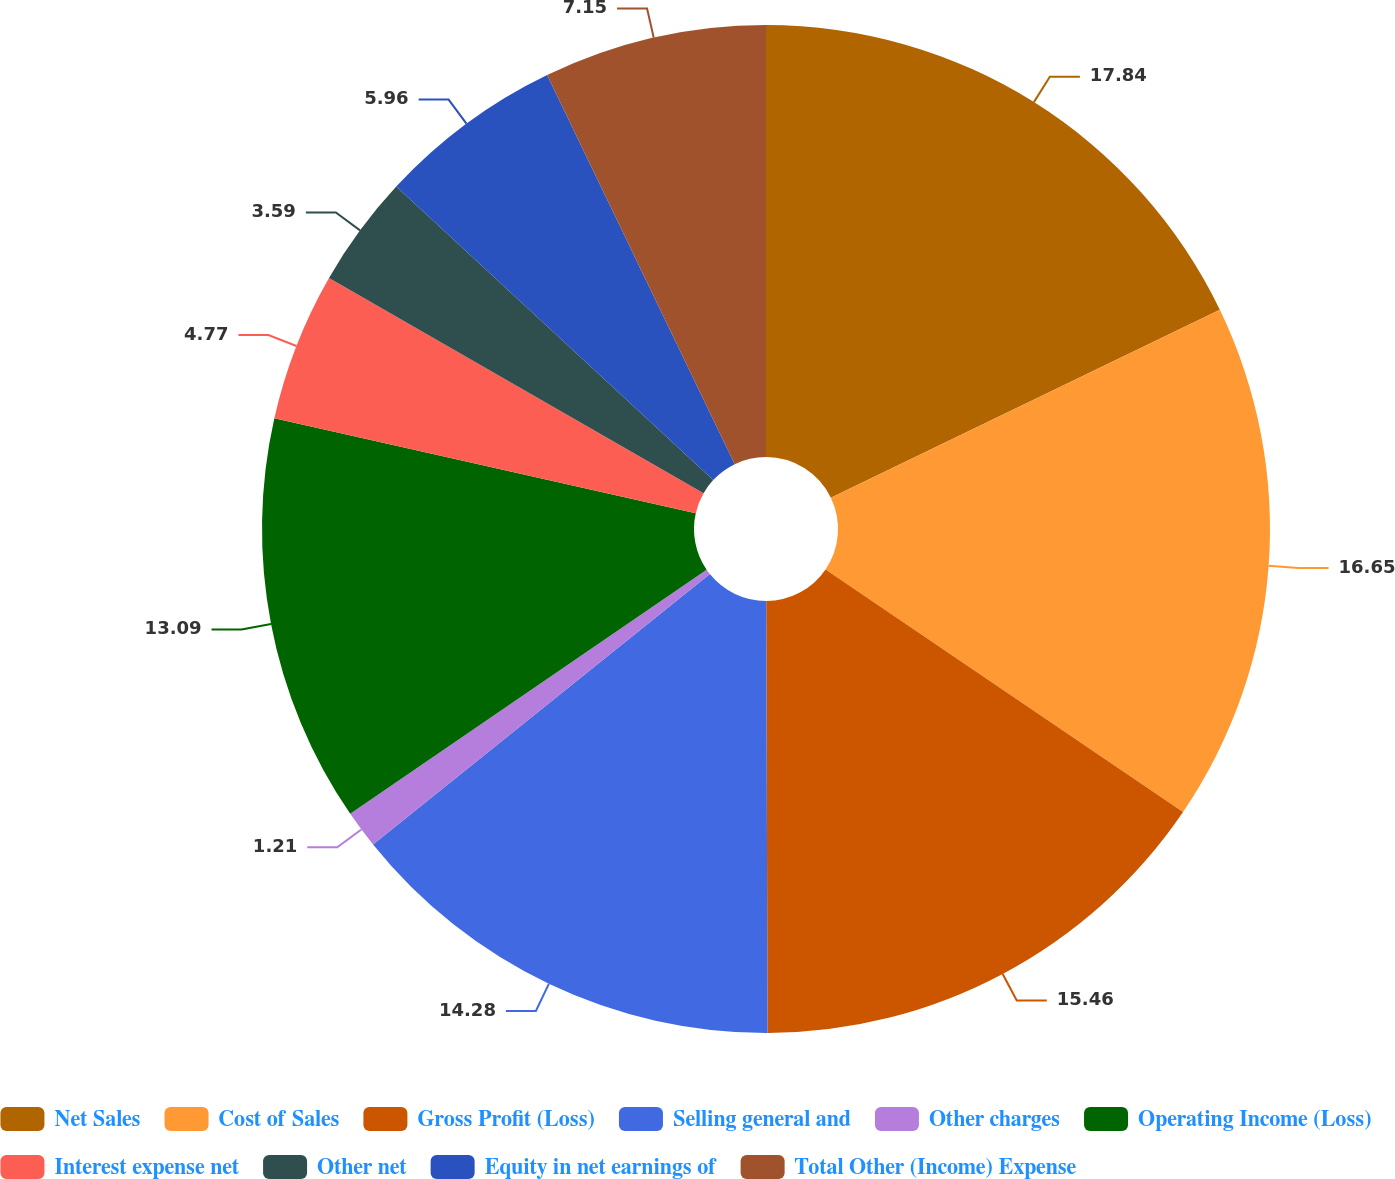Convert chart to OTSL. <chart><loc_0><loc_0><loc_500><loc_500><pie_chart><fcel>Net Sales<fcel>Cost of Sales<fcel>Gross Profit (Loss)<fcel>Selling general and<fcel>Other charges<fcel>Operating Income (Loss)<fcel>Interest expense net<fcel>Other net<fcel>Equity in net earnings of<fcel>Total Other (Income) Expense<nl><fcel>17.84%<fcel>16.65%<fcel>15.46%<fcel>14.28%<fcel>1.21%<fcel>13.09%<fcel>4.77%<fcel>3.59%<fcel>5.96%<fcel>7.15%<nl></chart> 